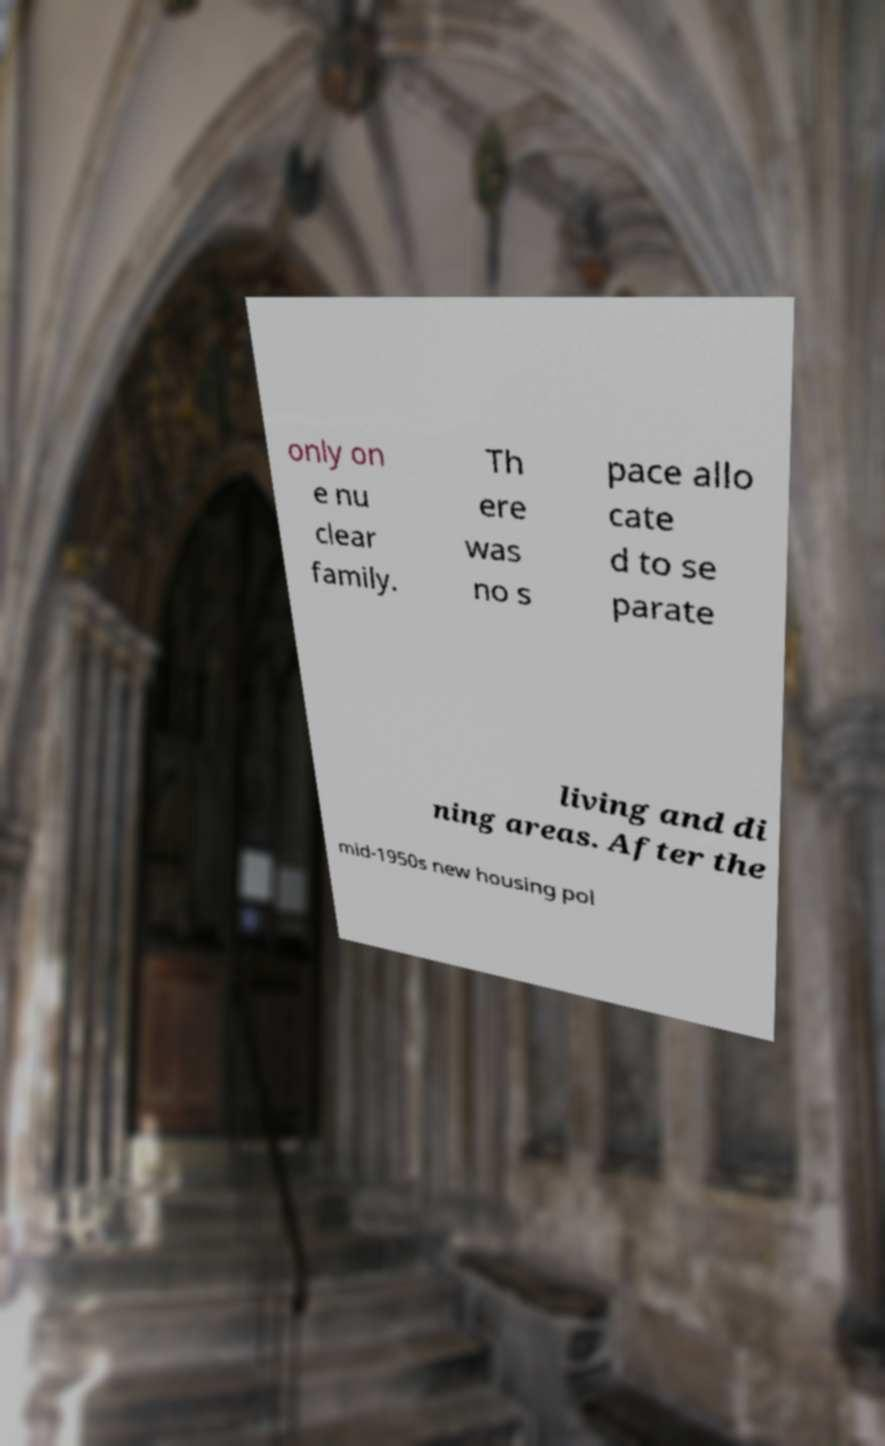Could you extract and type out the text from this image? only on e nu clear family. Th ere was no s pace allo cate d to se parate living and di ning areas. After the mid-1950s new housing pol 